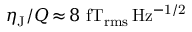<formula> <loc_0><loc_0><loc_500><loc_500>\eta _ { J } / Q \, { \approx } \, 8 f T _ { r m s } \, H z ^ { - 1 / 2 }</formula> 